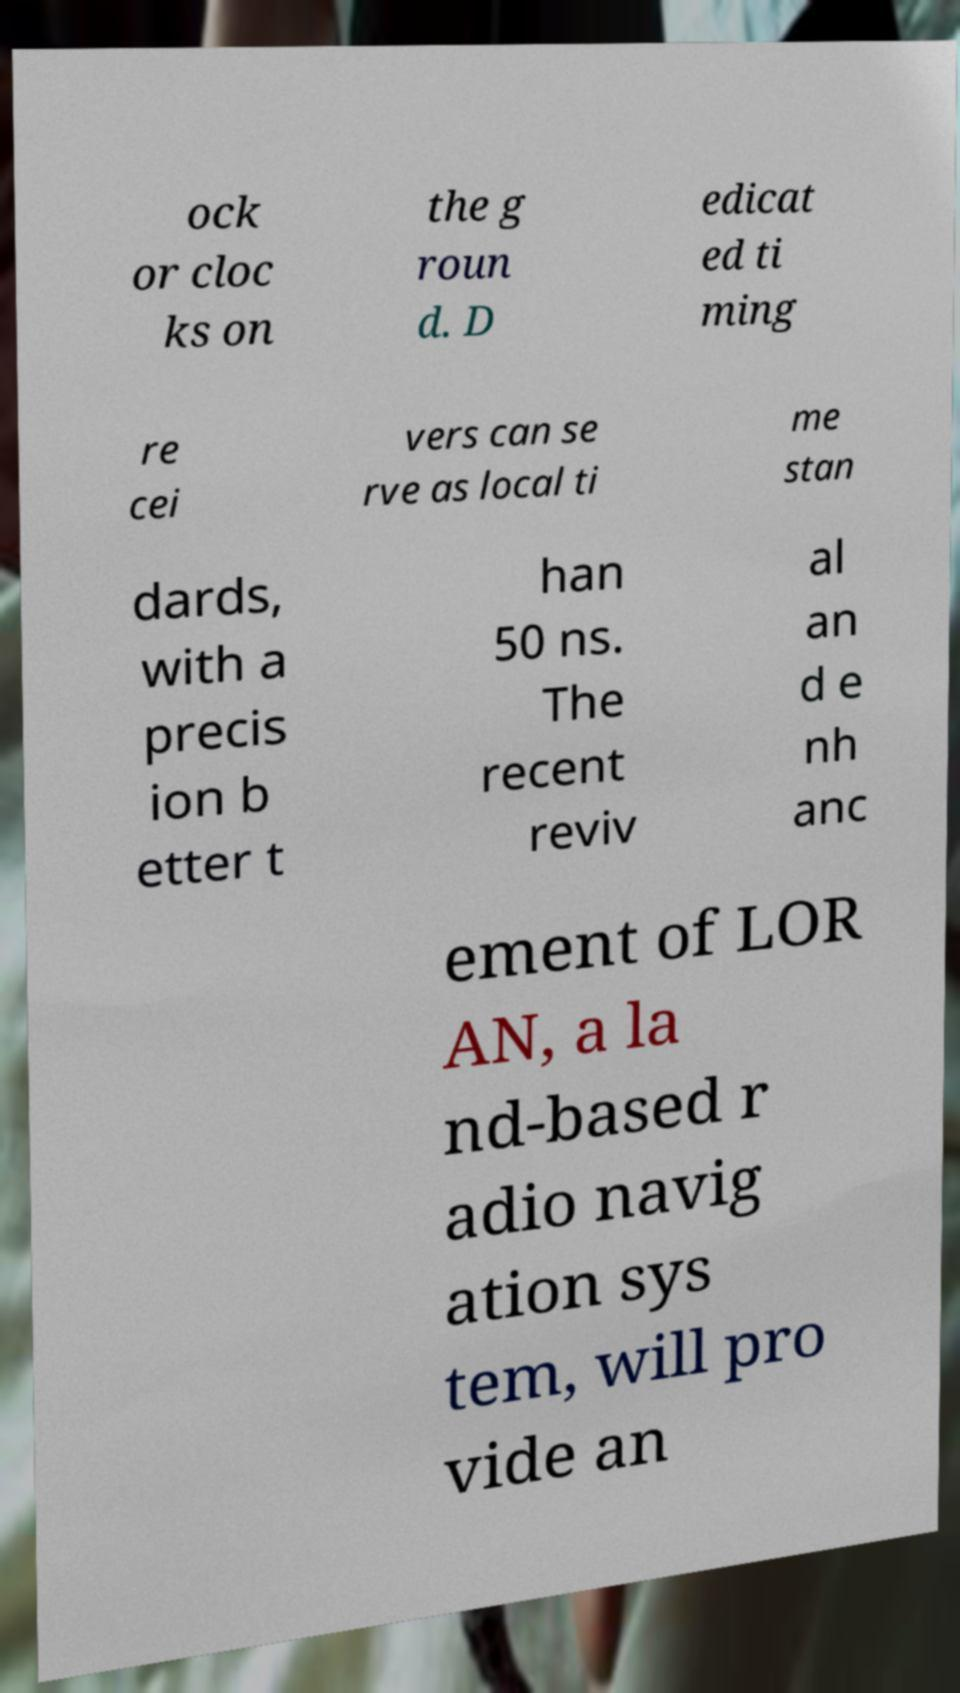Could you assist in decoding the text presented in this image and type it out clearly? ock or cloc ks on the g roun d. D edicat ed ti ming re cei vers can se rve as local ti me stan dards, with a precis ion b etter t han 50 ns. The recent reviv al an d e nh anc ement of LOR AN, a la nd-based r adio navig ation sys tem, will pro vide an 